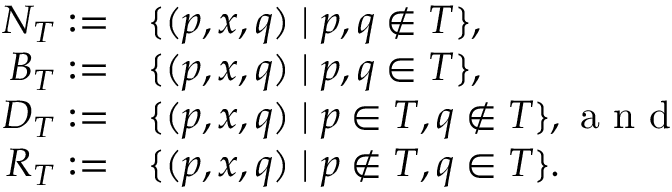<formula> <loc_0><loc_0><loc_500><loc_500>\begin{array} { r l } { N _ { T } \colon = } & { \{ ( p , x , q ) | p , q \not \in T \} , } \\ { B _ { T } \colon = } & { \{ ( p , x , q ) | p , q \in T \} , } \\ { D _ { T } \colon = } & { \{ ( p , x , q ) | p \in T , q \not \in T \} , a n d } \\ { R _ { T } \colon = } & { \{ ( p , x , q ) | p \not \in T , q \in T \} . } \end{array}</formula> 